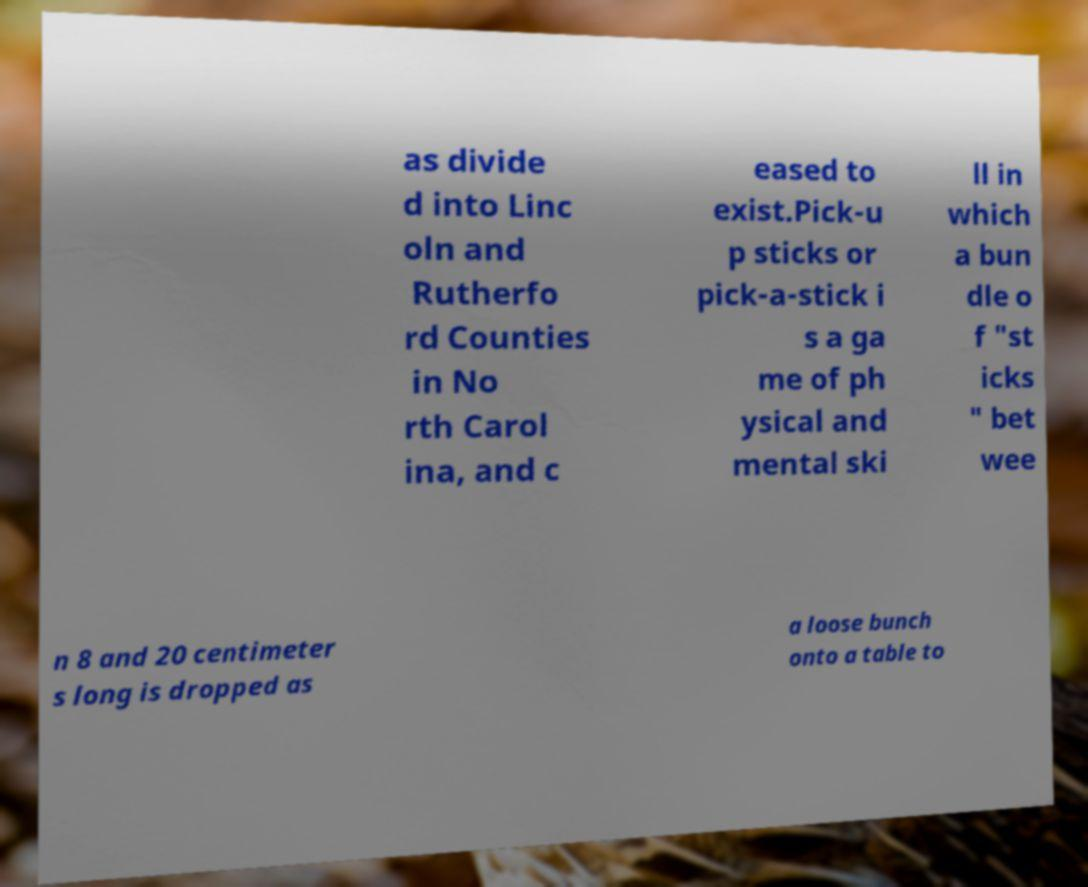For documentation purposes, I need the text within this image transcribed. Could you provide that? as divide d into Linc oln and Rutherfo rd Counties in No rth Carol ina, and c eased to exist.Pick-u p sticks or pick-a-stick i s a ga me of ph ysical and mental ski ll in which a bun dle o f "st icks " bet wee n 8 and 20 centimeter s long is dropped as a loose bunch onto a table to 